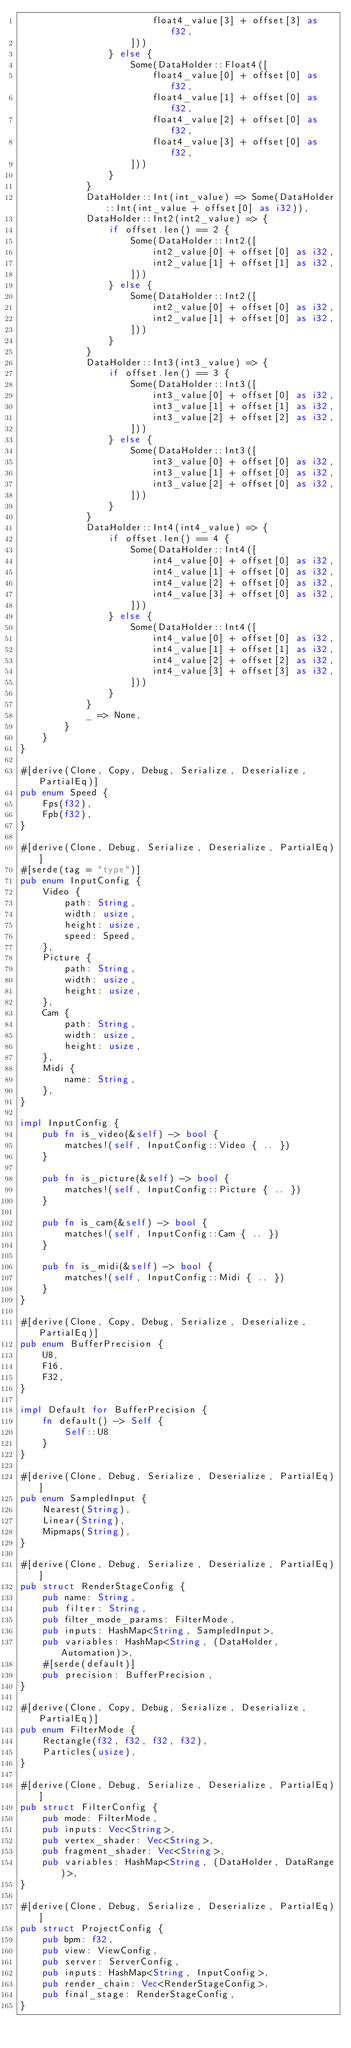<code> <loc_0><loc_0><loc_500><loc_500><_Rust_>                        float4_value[3] + offset[3] as f32,
                    ]))
                } else {
                    Some(DataHolder::Float4([
                        float4_value[0] + offset[0] as f32,
                        float4_value[1] + offset[0] as f32,
                        float4_value[2] + offset[0] as f32,
                        float4_value[3] + offset[0] as f32,
                    ]))
                }
            }
            DataHolder::Int(int_value) => Some(DataHolder::Int(int_value + offset[0] as i32)),
            DataHolder::Int2(int2_value) => {
                if offset.len() == 2 {
                    Some(DataHolder::Int2([
                        int2_value[0] + offset[0] as i32,
                        int2_value[1] + offset[1] as i32,
                    ]))
                } else {
                    Some(DataHolder::Int2([
                        int2_value[0] + offset[0] as i32,
                        int2_value[1] + offset[0] as i32,
                    ]))
                }
            }
            DataHolder::Int3(int3_value) => {
                if offset.len() == 3 {
                    Some(DataHolder::Int3([
                        int3_value[0] + offset[0] as i32,
                        int3_value[1] + offset[1] as i32,
                        int3_value[2] + offset[2] as i32,
                    ]))
                } else {
                    Some(DataHolder::Int3([
                        int3_value[0] + offset[0] as i32,
                        int3_value[1] + offset[0] as i32,
                        int3_value[2] + offset[0] as i32,
                    ]))
                }
            }
            DataHolder::Int4(int4_value) => {
                if offset.len() == 4 {
                    Some(DataHolder::Int4([
                        int4_value[0] + offset[0] as i32,
                        int4_value[1] + offset[0] as i32,
                        int4_value[2] + offset[0] as i32,
                        int4_value[3] + offset[0] as i32,
                    ]))
                } else {
                    Some(DataHolder::Int4([
                        int4_value[0] + offset[0] as i32,
                        int4_value[1] + offset[1] as i32,
                        int4_value[2] + offset[2] as i32,
                        int4_value[3] + offset[3] as i32,
                    ]))
                }
            }
            _ => None,
        }
    }
}

#[derive(Clone, Copy, Debug, Serialize, Deserialize, PartialEq)]
pub enum Speed {
    Fps(f32),
    Fpb(f32),
}

#[derive(Clone, Debug, Serialize, Deserialize, PartialEq)]
#[serde(tag = "type")]
pub enum InputConfig {
    Video {
        path: String,
        width: usize,
        height: usize,
        speed: Speed,
    },
    Picture {
        path: String,
        width: usize,
        height: usize,
    },
    Cam {
        path: String,
        width: usize,
        height: usize,
    },
    Midi {
        name: String,
    },
}

impl InputConfig {
    pub fn is_video(&self) -> bool {
        matches!(self, InputConfig::Video { .. })
    }

    pub fn is_picture(&self) -> bool {
        matches!(self, InputConfig::Picture { .. })
    }

    pub fn is_cam(&self) -> bool {
        matches!(self, InputConfig::Cam { .. })
    }

    pub fn is_midi(&self) -> bool {
        matches!(self, InputConfig::Midi { .. })
    }
}

#[derive(Clone, Copy, Debug, Serialize, Deserialize, PartialEq)]
pub enum BufferPrecision {
    U8,
    F16,
    F32,
}

impl Default for BufferPrecision {
    fn default() -> Self {
        Self::U8
    }
}

#[derive(Clone, Debug, Serialize, Deserialize, PartialEq)]
pub enum SampledInput {
    Nearest(String),
    Linear(String),
    Mipmaps(String),
}

#[derive(Clone, Debug, Serialize, Deserialize, PartialEq)]
pub struct RenderStageConfig {
    pub name: String,
    pub filter: String,
    pub filter_mode_params: FilterMode,
    pub inputs: HashMap<String, SampledInput>,
    pub variables: HashMap<String, (DataHolder, Automation)>,
    #[serde(default)]
    pub precision: BufferPrecision,
}

#[derive(Clone, Copy, Debug, Serialize, Deserialize, PartialEq)]
pub enum FilterMode {
    Rectangle(f32, f32, f32, f32),
    Particles(usize),
}

#[derive(Clone, Debug, Serialize, Deserialize, PartialEq)]
pub struct FilterConfig {
    pub mode: FilterMode,
    pub inputs: Vec<String>,
    pub vertex_shader: Vec<String>,
    pub fragment_shader: Vec<String>,
    pub variables: HashMap<String, (DataHolder, DataRange)>,
}

#[derive(Clone, Debug, Serialize, Deserialize, PartialEq)]
pub struct ProjectConfig {
    pub bpm: f32,
    pub view: ViewConfig,
    pub server: ServerConfig,
    pub inputs: HashMap<String, InputConfig>,
    pub render_chain: Vec<RenderStageConfig>,
    pub final_stage: RenderStageConfig,
}
</code> 